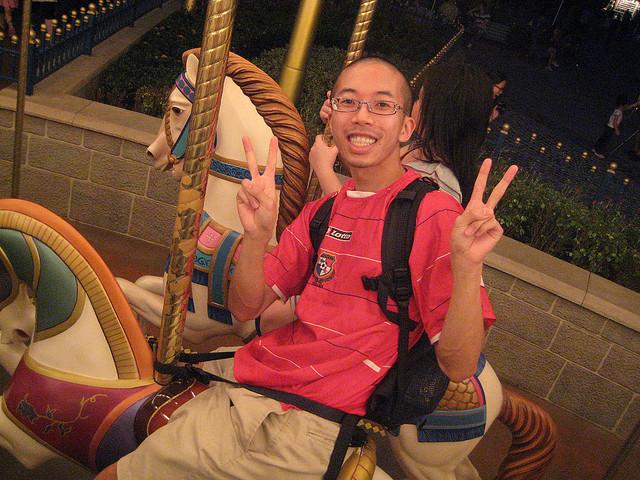Is the guy in this picture wearing glasses?
Give a very brief answer. Yes. How many fingers is he holding up?
Answer briefly. 4. What is the man on?
Quick response, please. Carousel. 